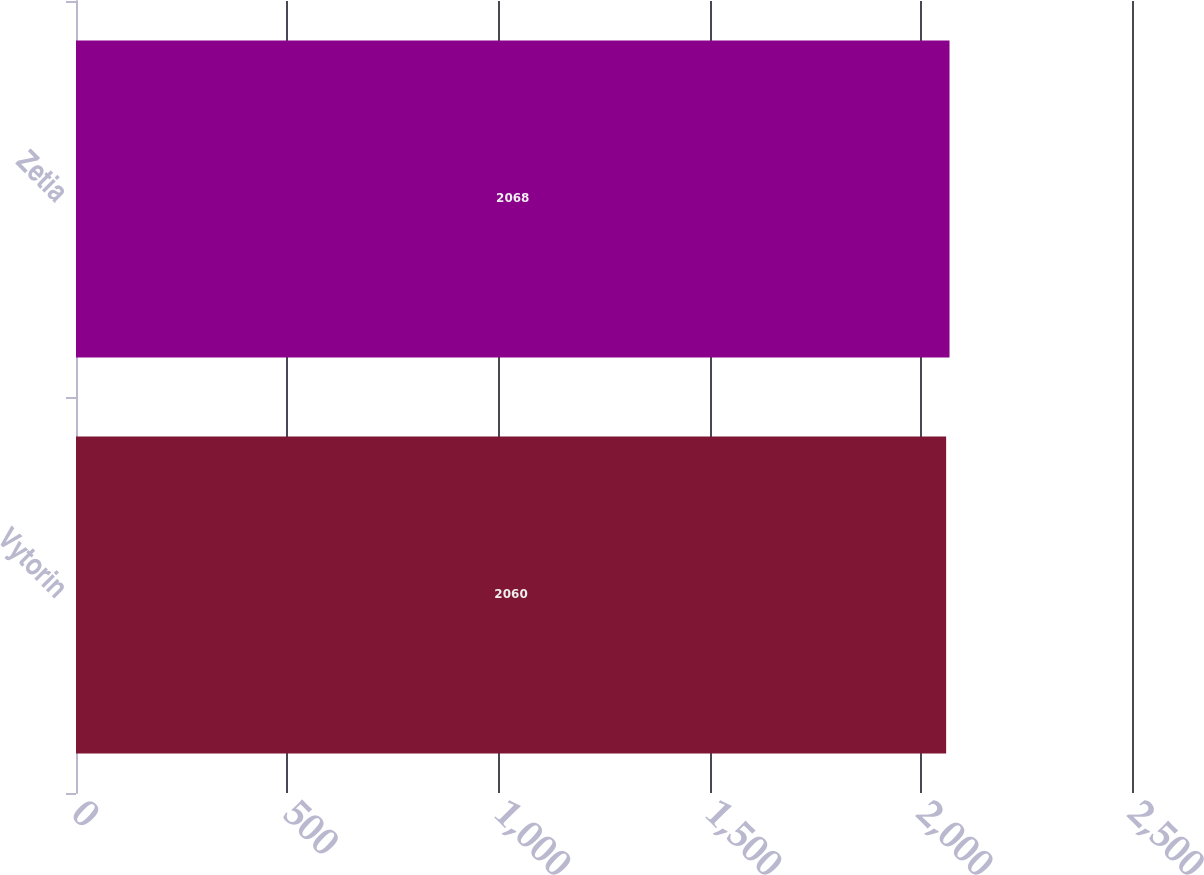<chart> <loc_0><loc_0><loc_500><loc_500><bar_chart><fcel>Vytorin<fcel>Zetia<nl><fcel>2060<fcel>2068<nl></chart> 